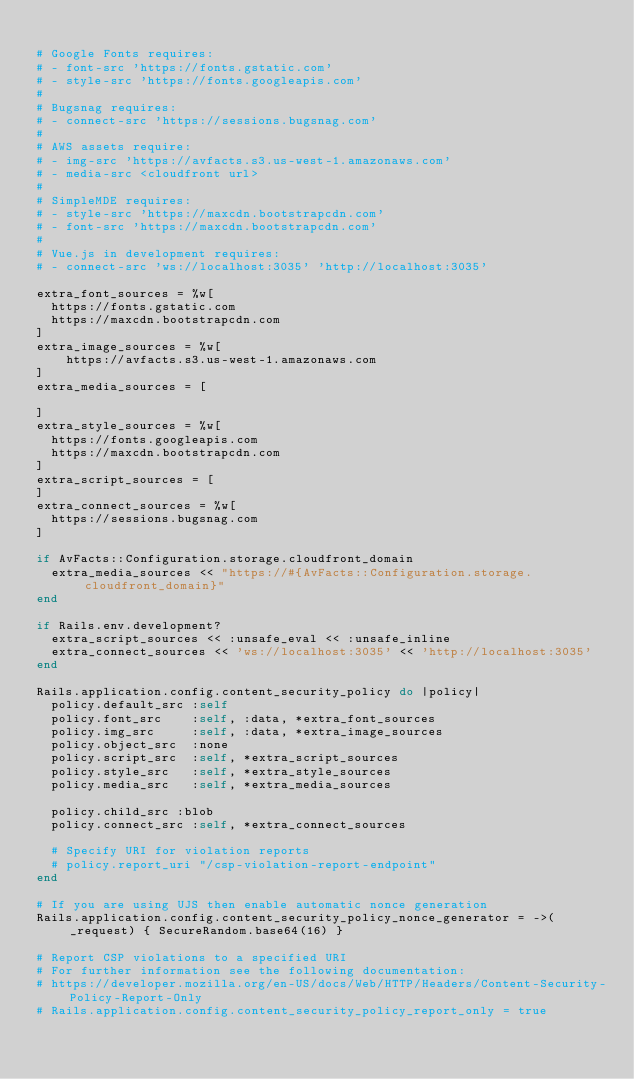Convert code to text. <code><loc_0><loc_0><loc_500><loc_500><_Ruby_>
# Google Fonts requires:
# - font-src 'https://fonts.gstatic.com'
# - style-src 'https://fonts.googleapis.com'
#
# Bugsnag requires:
# - connect-src 'https://sessions.bugsnag.com'
#
# AWS assets require:
# - img-src 'https://avfacts.s3.us-west-1.amazonaws.com'
# - media-src <cloudfront url>
#
# SimpleMDE requires:
# - style-src 'https://maxcdn.bootstrapcdn.com'
# - font-src 'https://maxcdn.bootstrapcdn.com'
#
# Vue.js in development requires:
# - connect-src 'ws://localhost:3035' 'http://localhost:3035'

extra_font_sources = %w[
  https://fonts.gstatic.com
  https://maxcdn.bootstrapcdn.com
]
extra_image_sources = %w[
    https://avfacts.s3.us-west-1.amazonaws.com
]
extra_media_sources = [

]
extra_style_sources = %w[
  https://fonts.googleapis.com
  https://maxcdn.bootstrapcdn.com
]
extra_script_sources = [
]
extra_connect_sources = %w[
  https://sessions.bugsnag.com
]

if AvFacts::Configuration.storage.cloudfront_domain
  extra_media_sources << "https://#{AvFacts::Configuration.storage.cloudfront_domain}"
end

if Rails.env.development?
  extra_script_sources << :unsafe_eval << :unsafe_inline
  extra_connect_sources << 'ws://localhost:3035' << 'http://localhost:3035'
end

Rails.application.config.content_security_policy do |policy|
  policy.default_src :self
  policy.font_src    :self, :data, *extra_font_sources
  policy.img_src     :self, :data, *extra_image_sources
  policy.object_src  :none
  policy.script_src  :self, *extra_script_sources
  policy.style_src   :self, *extra_style_sources
  policy.media_src   :self, *extra_media_sources

  policy.child_src :blob
  policy.connect_src :self, *extra_connect_sources

  # Specify URI for violation reports
  # policy.report_uri "/csp-violation-report-endpoint"
end

# If you are using UJS then enable automatic nonce generation
Rails.application.config.content_security_policy_nonce_generator = ->(_request) { SecureRandom.base64(16) }

# Report CSP violations to a specified URI
# For further information see the following documentation:
# https://developer.mozilla.org/en-US/docs/Web/HTTP/Headers/Content-Security-Policy-Report-Only
# Rails.application.config.content_security_policy_report_only = true
</code> 